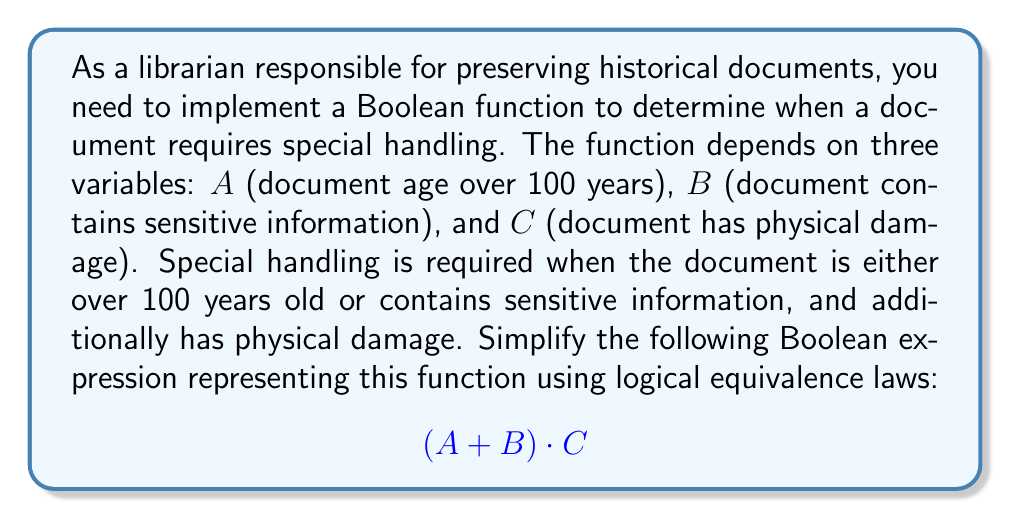Can you answer this question? Let's simplify the given Boolean expression $(A + B) \cdot C$ step by step:

1. The expression is already in a relatively simple form, but we can verify if any further simplification is possible using the distributive law.

2. Apply the distributive law: $(A + B) \cdot C = (A \cdot C) + (B \cdot C)$

3. This expanded form $(A \cdot C) + (B \cdot C)$ is actually the most simplified version of the expression. It cannot be reduced further because:
   - $A$ and $B$ are different variables, so they cannot be combined.
   - $C$ is common to both terms, but factoring it out would return us to the original expression.

4. Therefore, the final simplified expression is:

   $$(A \cdot C) + (B \cdot C)$$

This simplified form clearly shows that special handling is required when either:
- The document is over 100 years old $(A)$ AND has physical damage $(C)$, OR
- The document contains sensitive information $(B)$ AND has physical damage $(C)$.

This matches our original requirements and preserves the logical meaning of the function.
Answer: $(A \cdot C) + (B \cdot C)$ 